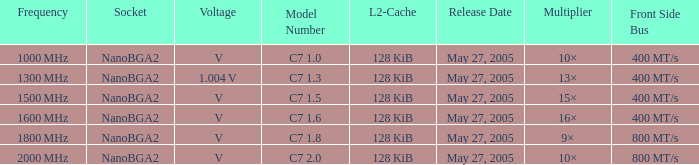What is the recurrence for model number c7 1000 MHz. 